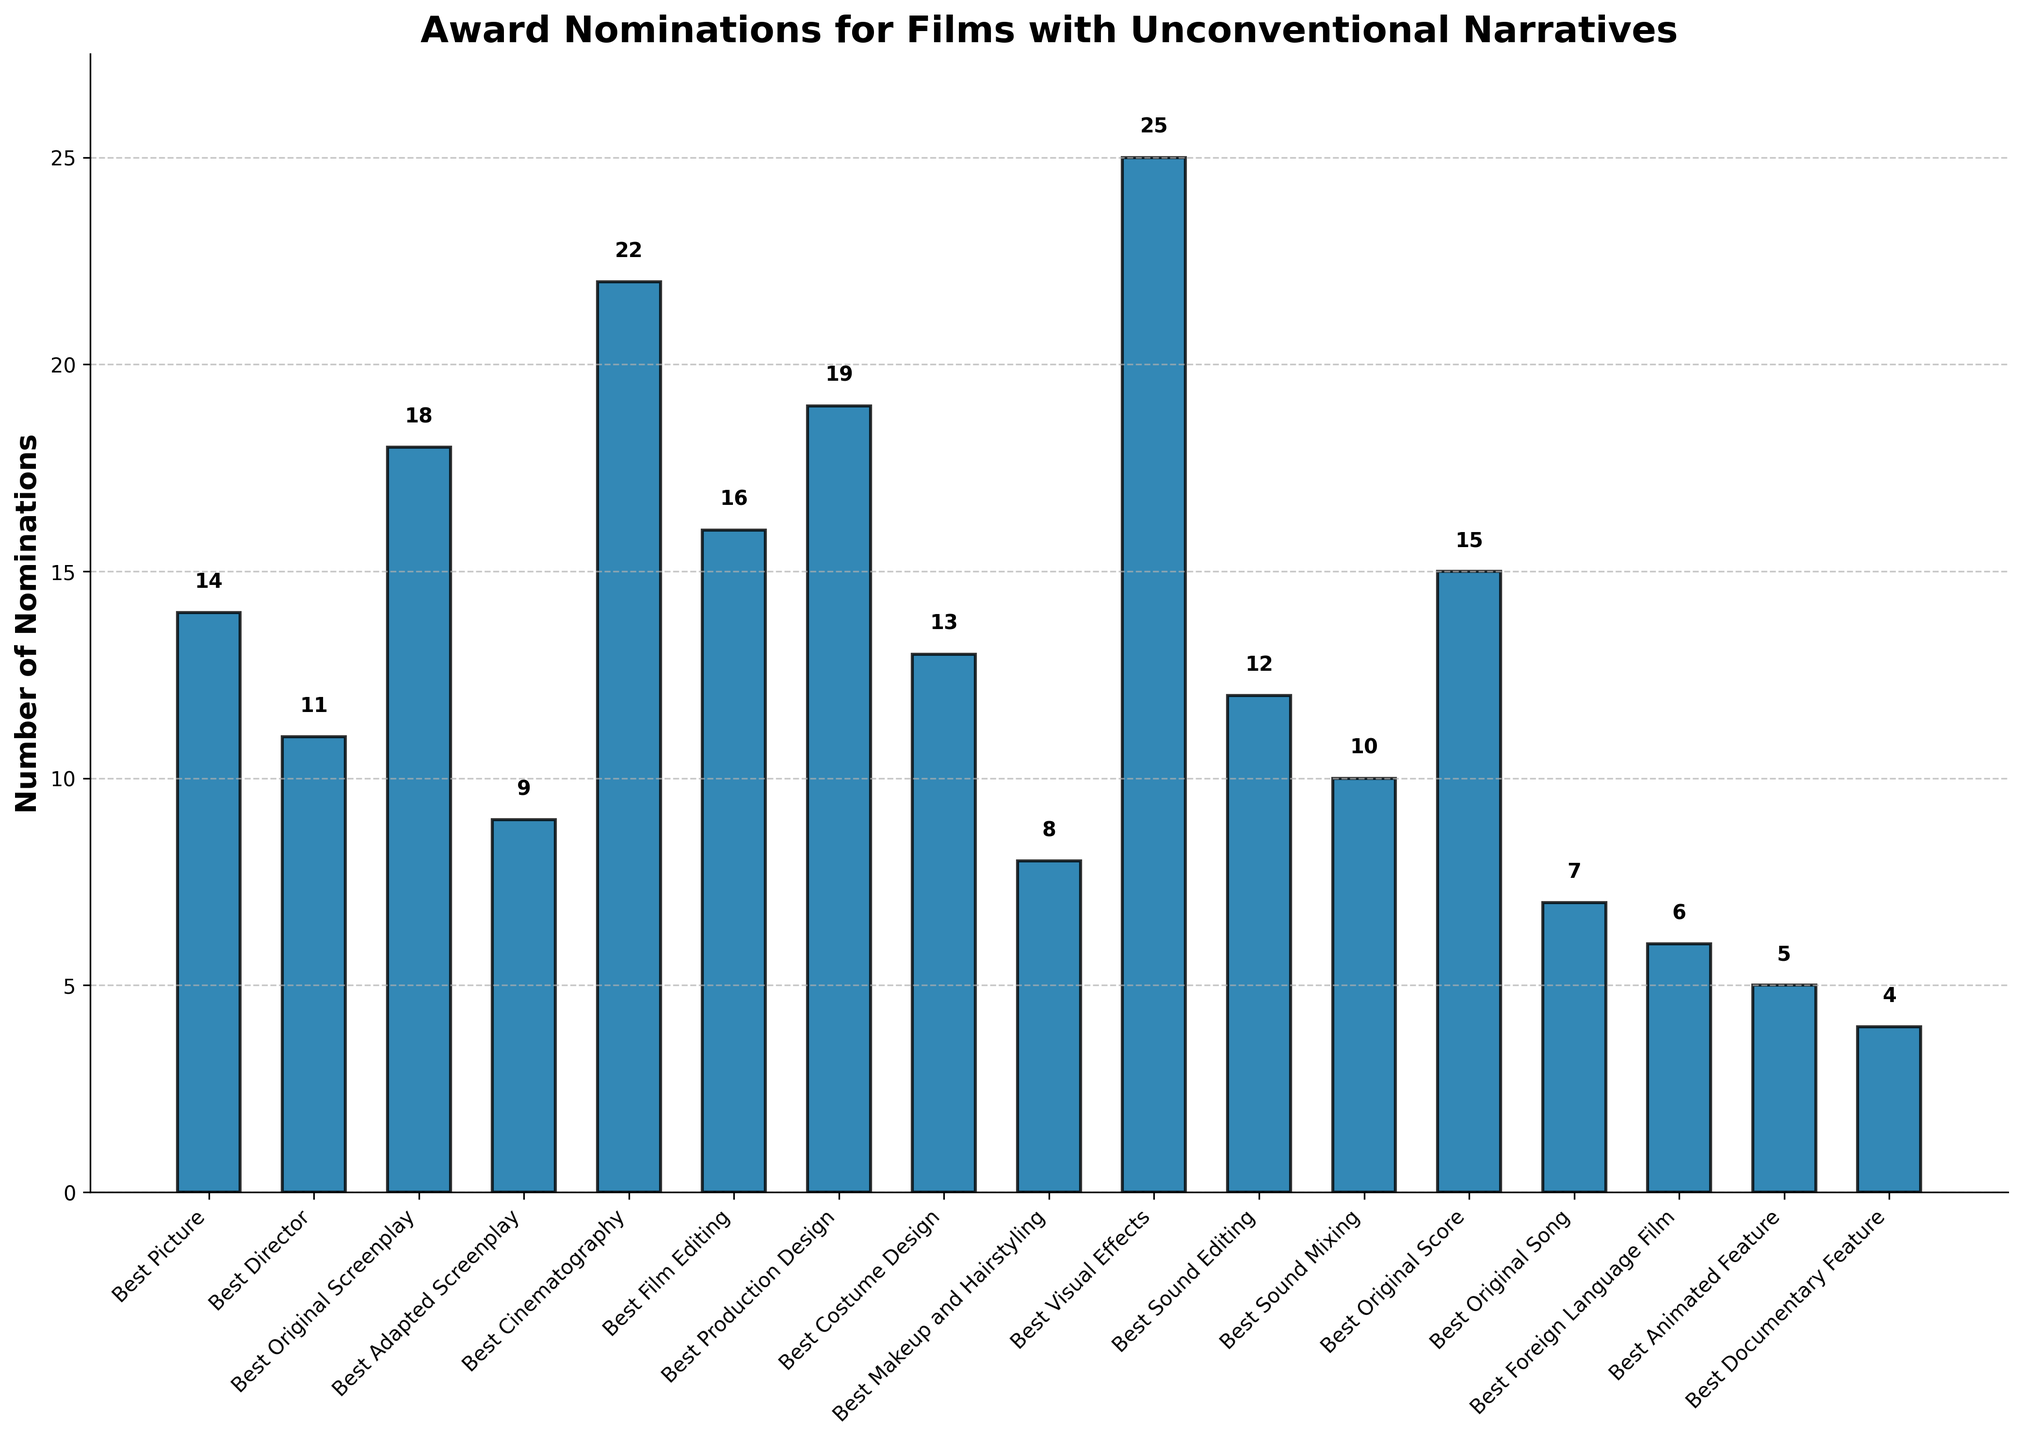Which award category has the highest number of nominations? The Best Visual Effects category has the highest bar height, indicating that it has the highest number of nominations.
Answer: Best Visual Effects Which award category has the lowest number of nominations? The Best Documentary Feature category has the shortest bar, indicating that it has the lowest number of nominations.
Answer: Best Documentary Feature How many nominations were received for Best Original Screenplay and Best Adapted Screenplay combined? Best Original Screenplay has 18 nominations, and Best Adapted Screenplay has 9 nominations. Adding them together gives 18 + 9 = 27.
Answer: 27 Which categories have more nominations: Best Sound Editing and Best Sound Mixing combined or Best Cinematography? Best Sound Editing has 12 nominations, and Best Sound Mixing has 10 nominations. Combined, they have 12 + 10 = 22 nominations, which is equal to the number of nominations for Best Cinematography.
Answer: They are equal Are there more nominations for Best Production Design or Best Picture? Best Production Design has 19 nominations, while Best Picture has 14 nominations. 19 is greater than 14.
Answer: Best Production Design How many more nominations does Best Visual Effects have compared to Best Sound Mixing? Best Visual Effects has 25 nominations, and Best Sound Mixing has 10 nominations. The difference is 25 - 10 = 15.
Answer: 15 What is the difference between the highest and the lowest number of nominations? The highest number of nominations is 25 (Best Visual Effects), and the lowest is 4 (Best Documentary Feature). The difference is 25 - 4 = 21.
Answer: 21 Which three categories have the highest number of nominations? The three highest bars belong to Best Visual Effects (25), Best Cinematography (22), and Best Production Design (19).
Answer: Best Visual Effects, Best Cinematography, Best Production Design What's the average number of nominations across all categories? Summing all nominations: 14+11+18+9+22+16+19+13+8+25+12+10+15+7+6+5+4 = 214. There are 17 categories. Average = 214/17 ≈ 12.59.
Answer: Approximately 12.59 What is the total number of nominations for categories related to "Sound" (Best Sound Editing and Best Sound Mixing)? Best Sound Editing has 12 nominations, and Best Sound Mixing has 10 nominations. Total = 12 + 10 = 22.
Answer: 22 